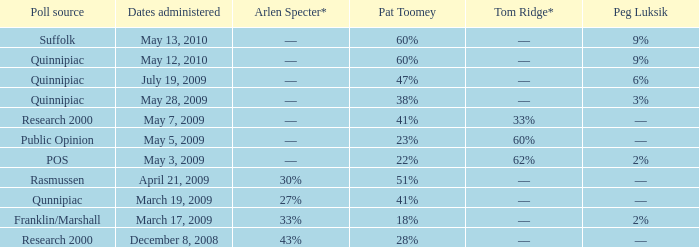Which Poll source has an Arlen Specter* of ––, and a Tom Ridge* of 60%? Public Opinion. 